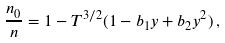Convert formula to latex. <formula><loc_0><loc_0><loc_500><loc_500>\frac { n _ { 0 } } { n } = 1 - T ^ { 3 / 2 } ( 1 - b _ { 1 } y + b _ { 2 } y ^ { 2 } ) \, ,</formula> 